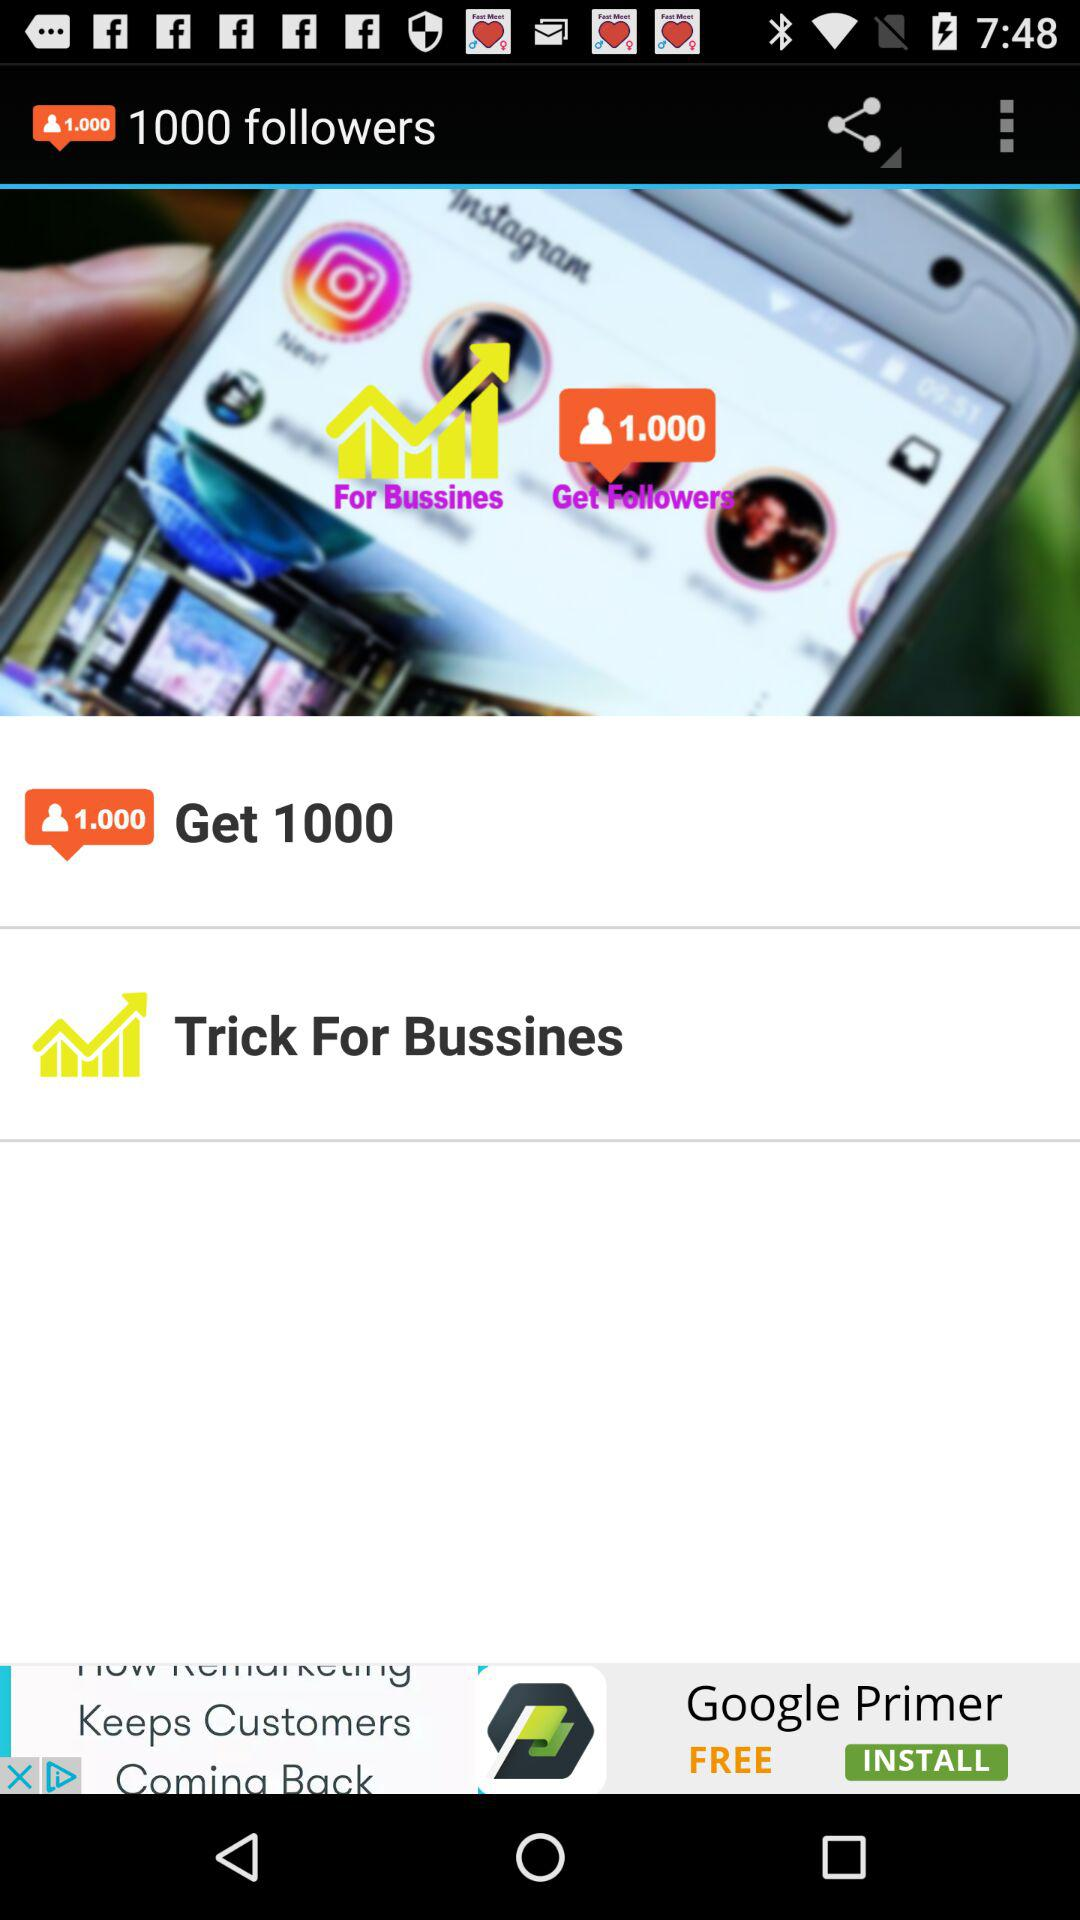How many followers can we get? You can get 1000 followers. 